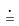Convert formula to latex. <formula><loc_0><loc_0><loc_500><loc_500>\dot { = }</formula> 